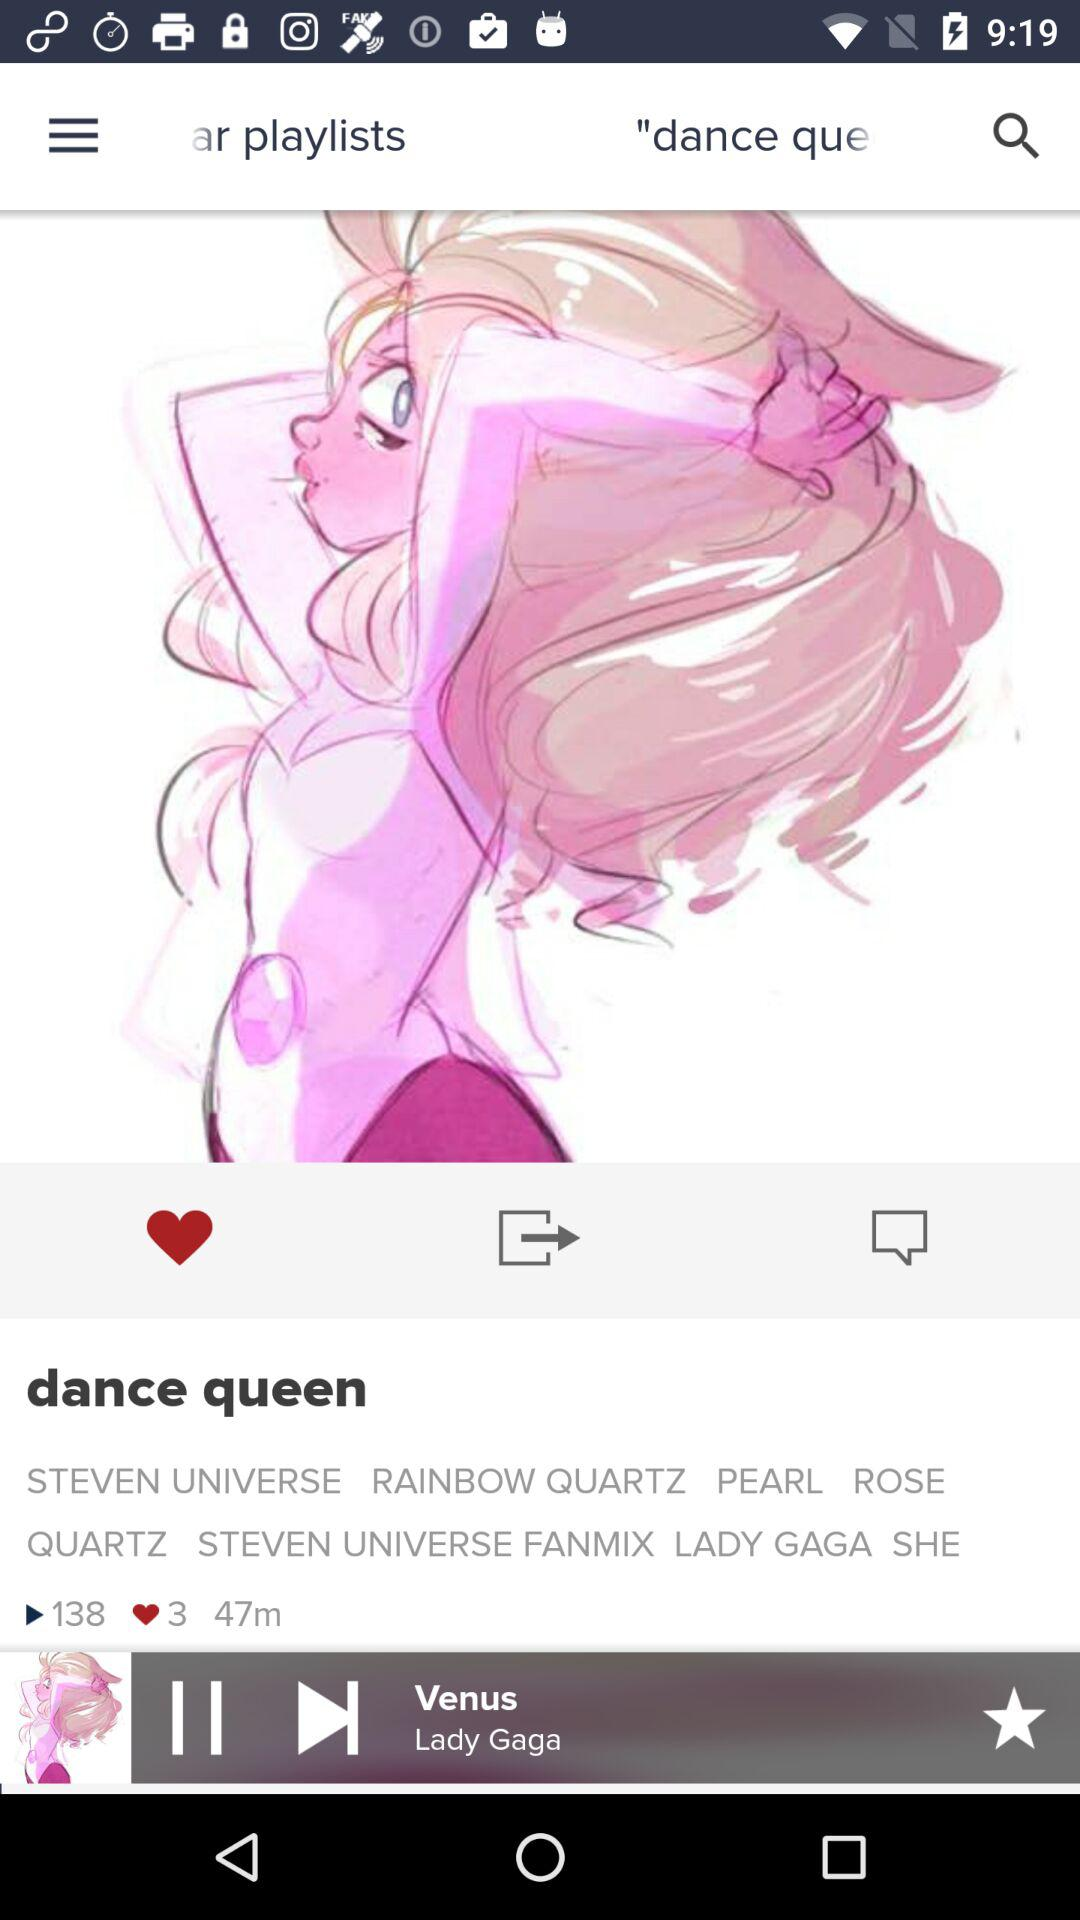What is the total duration of the playlist? The total duration of the playlist is 47 minutes. 